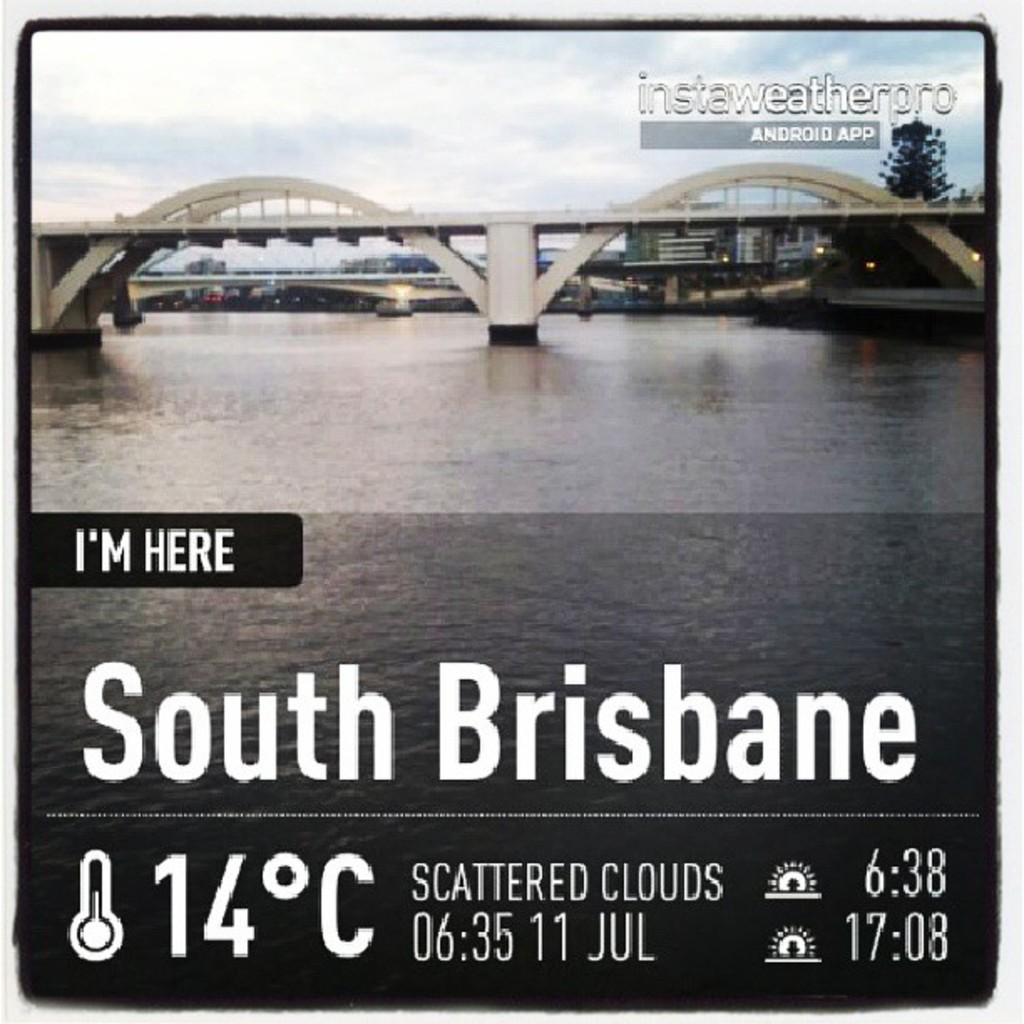What is the time?
Give a very brief answer. 6:35. 